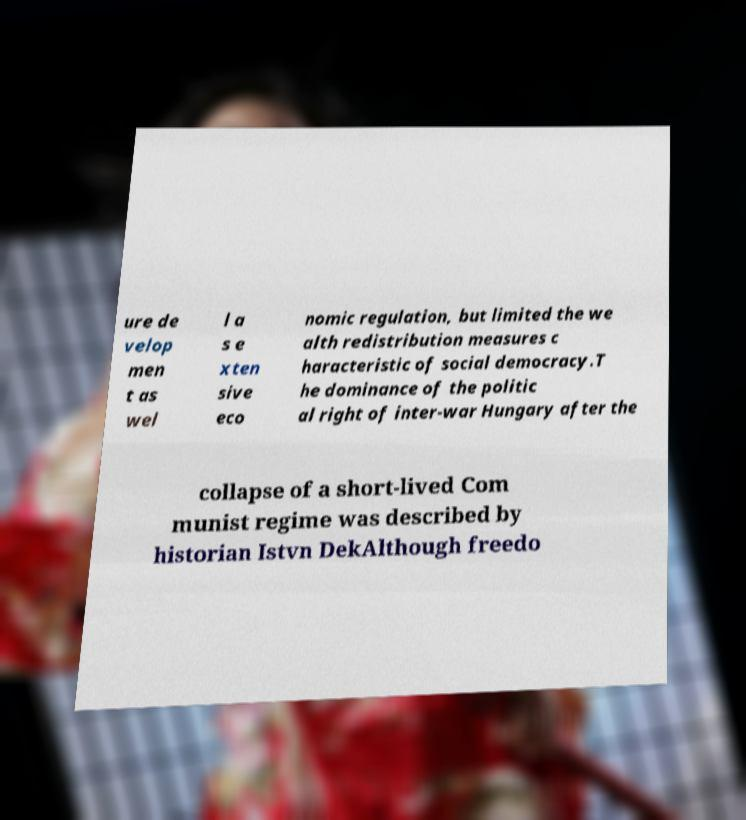Could you extract and type out the text from this image? ure de velop men t as wel l a s e xten sive eco nomic regulation, but limited the we alth redistribution measures c haracteristic of social democracy.T he dominance of the politic al right of inter-war Hungary after the collapse of a short-lived Com munist regime was described by historian Istvn DekAlthough freedo 